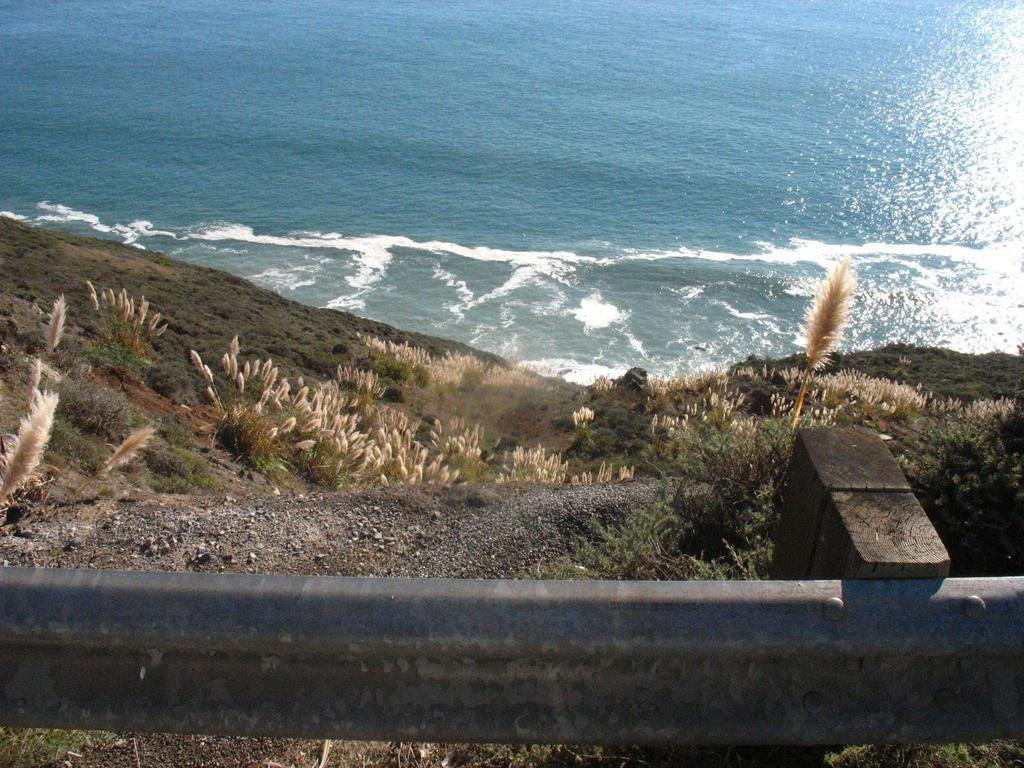What can be seen in the right corner of the image? There is a fence in the right corner of the image. What type of surface is present in the image? There is a greenery ground in the image. What is located near the ground? There are plants beside the ground. What can be seen in the distance in the image? There is water visible in the background of the image. What type of smile can be seen on the plants in the image? There are no smiles present in the image, as plants do not have facial expressions. What kind of meal is being prepared in the background of the image? There is no meal preparation visible in the image; it primarily features a fence, greenery ground, plants, and water in the background. 